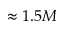Convert formula to latex. <formula><loc_0><loc_0><loc_500><loc_500>\approx 1 . 5 M</formula> 